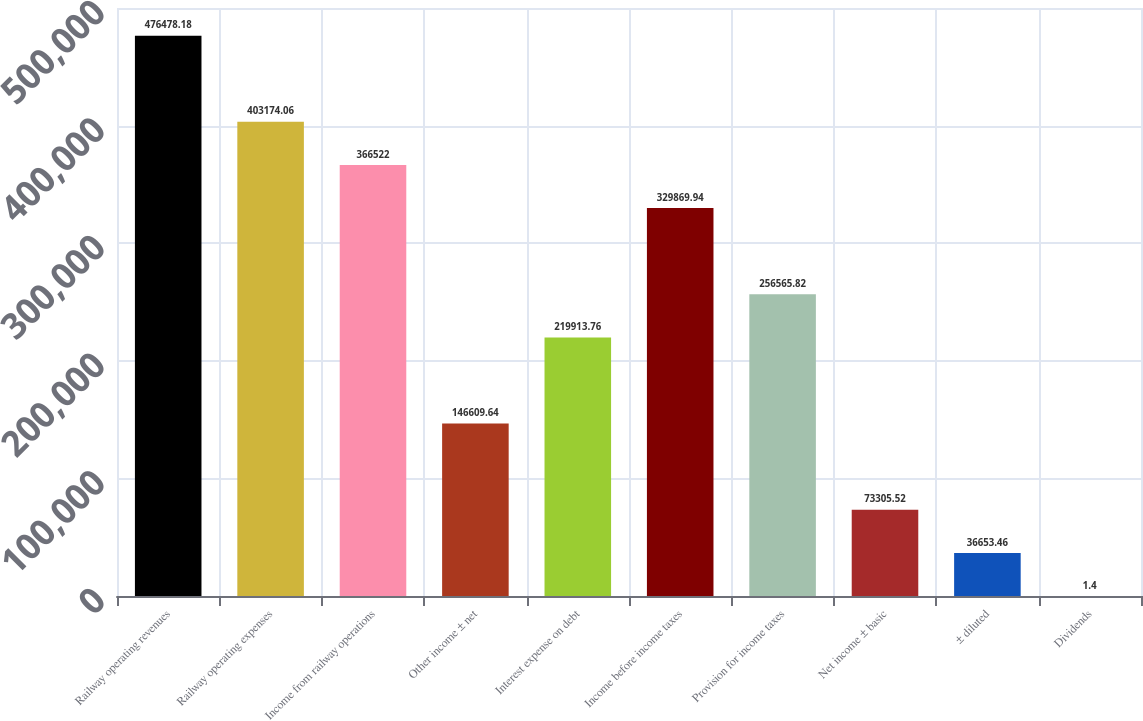<chart> <loc_0><loc_0><loc_500><loc_500><bar_chart><fcel>Railway operating revenues<fcel>Railway operating expenses<fcel>Income from railway operations<fcel>Other income ± net<fcel>Interest expense on debt<fcel>Income before income taxes<fcel>Provision for income taxes<fcel>Net income ± basic<fcel>± diluted<fcel>Dividends<nl><fcel>476478<fcel>403174<fcel>366522<fcel>146610<fcel>219914<fcel>329870<fcel>256566<fcel>73305.5<fcel>36653.5<fcel>1.4<nl></chart> 